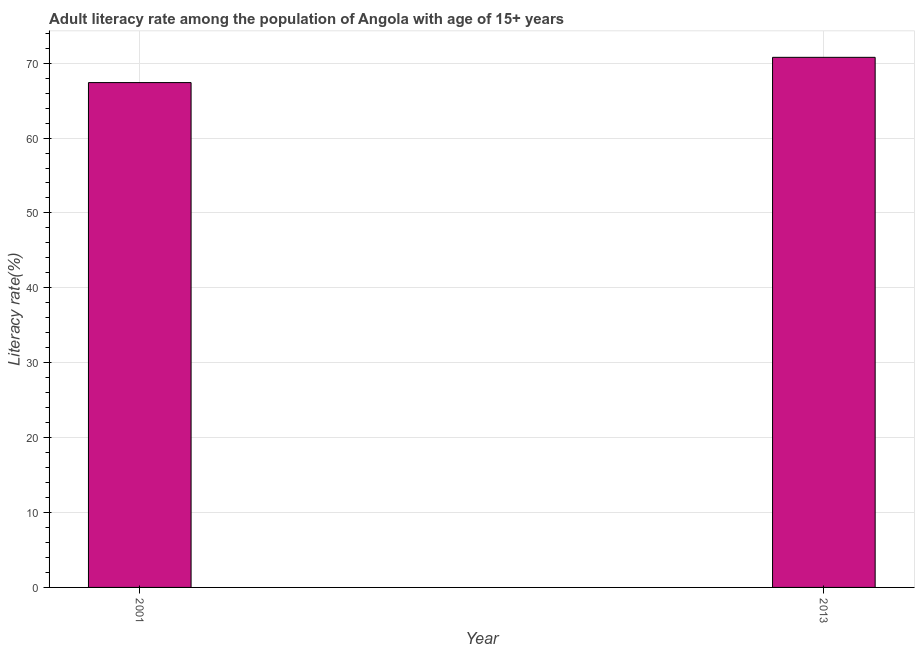Does the graph contain any zero values?
Provide a short and direct response. No. What is the title of the graph?
Make the answer very short. Adult literacy rate among the population of Angola with age of 15+ years. What is the label or title of the Y-axis?
Offer a terse response. Literacy rate(%). What is the adult literacy rate in 2001?
Make the answer very short. 67.41. Across all years, what is the maximum adult literacy rate?
Ensure brevity in your answer.  70.78. Across all years, what is the minimum adult literacy rate?
Provide a succinct answer. 67.41. What is the sum of the adult literacy rate?
Offer a very short reply. 138.18. What is the difference between the adult literacy rate in 2001 and 2013?
Provide a short and direct response. -3.37. What is the average adult literacy rate per year?
Give a very brief answer. 69.09. What is the median adult literacy rate?
Your response must be concise. 69.09. Is the adult literacy rate in 2001 less than that in 2013?
Offer a terse response. Yes. Are all the bars in the graph horizontal?
Your answer should be compact. No. What is the difference between two consecutive major ticks on the Y-axis?
Your response must be concise. 10. What is the Literacy rate(%) in 2001?
Make the answer very short. 67.41. What is the Literacy rate(%) in 2013?
Your answer should be very brief. 70.78. What is the difference between the Literacy rate(%) in 2001 and 2013?
Keep it short and to the point. -3.37. What is the ratio of the Literacy rate(%) in 2001 to that in 2013?
Make the answer very short. 0.95. 